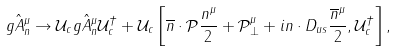Convert formula to latex. <formula><loc_0><loc_0><loc_500><loc_500>g \hat { A } _ { n } ^ { \mu } \rightarrow \mathcal { U } _ { c } g \hat { A } _ { n } ^ { \mu } \mathcal { U } _ { c } ^ { \dagger } + \mathcal { U } _ { c } \left [ \overline { n } \cdot \mathcal { P } \frac { n ^ { \mu } } { 2 } + \mathcal { P } _ { \perp } ^ { \mu } + i n \cdot D _ { u s } \frac { \overline { n } ^ { \mu } } { 2 } , \mathcal { U } _ { c } ^ { \dagger } \right ] ,</formula> 